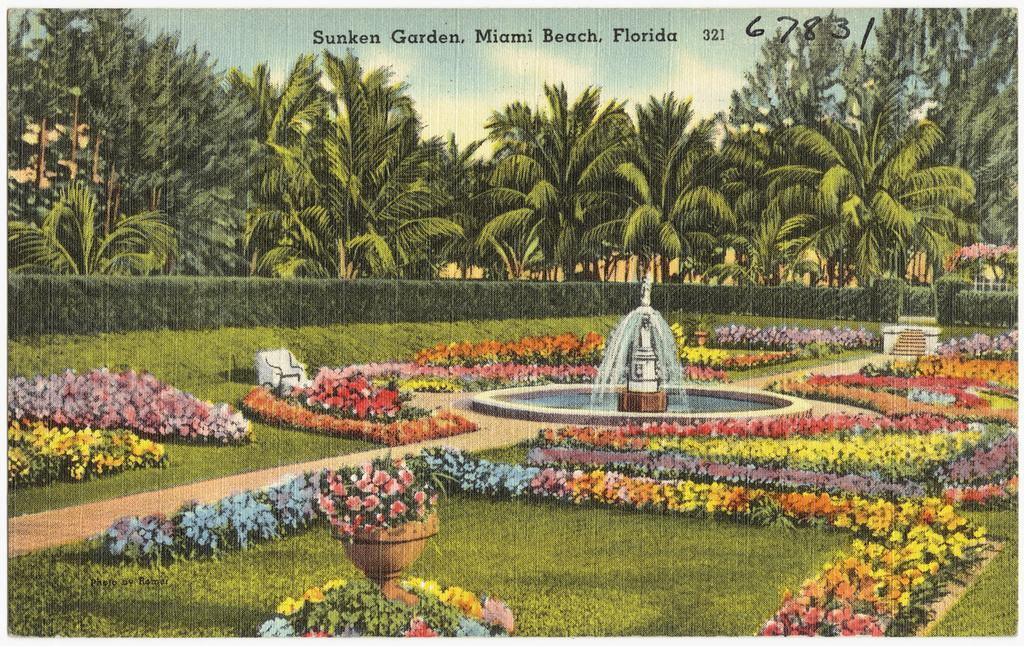What type of vegetation can be seen in the image? There are plants, flowers, and trees visible in the image. What is the ground covered with in the image? There is grass in the image. What is the main feature in the image? There is a fountain in the image. What can be seen in the background of the image? There are trees and the sky visible in the background of the image. What type of amusement ride is present in the image? There is no amusement ride present in the image; it features plants, flowers, grass, a fountain, trees, and the sky. What color is the coat worn by the person in the image? There is no person wearing a coat in the image. 